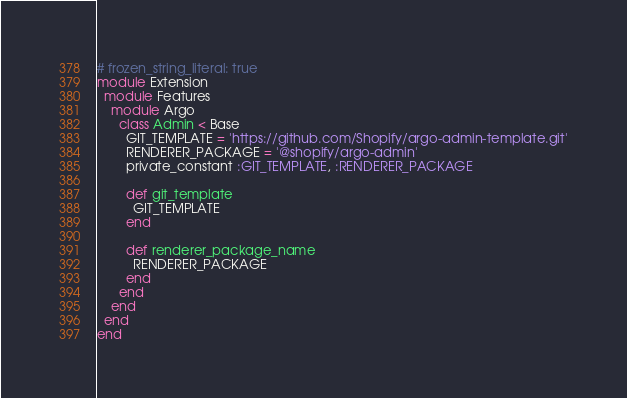Convert code to text. <code><loc_0><loc_0><loc_500><loc_500><_Ruby_># frozen_string_literal: true
module Extension
  module Features
    module Argo
      class Admin < Base
        GIT_TEMPLATE = 'https://github.com/Shopify/argo-admin-template.git'
        RENDERER_PACKAGE = '@shopify/argo-admin'
        private_constant :GIT_TEMPLATE, :RENDERER_PACKAGE

        def git_template
          GIT_TEMPLATE
        end

        def renderer_package_name
          RENDERER_PACKAGE
        end
      end
    end
  end
end
</code> 